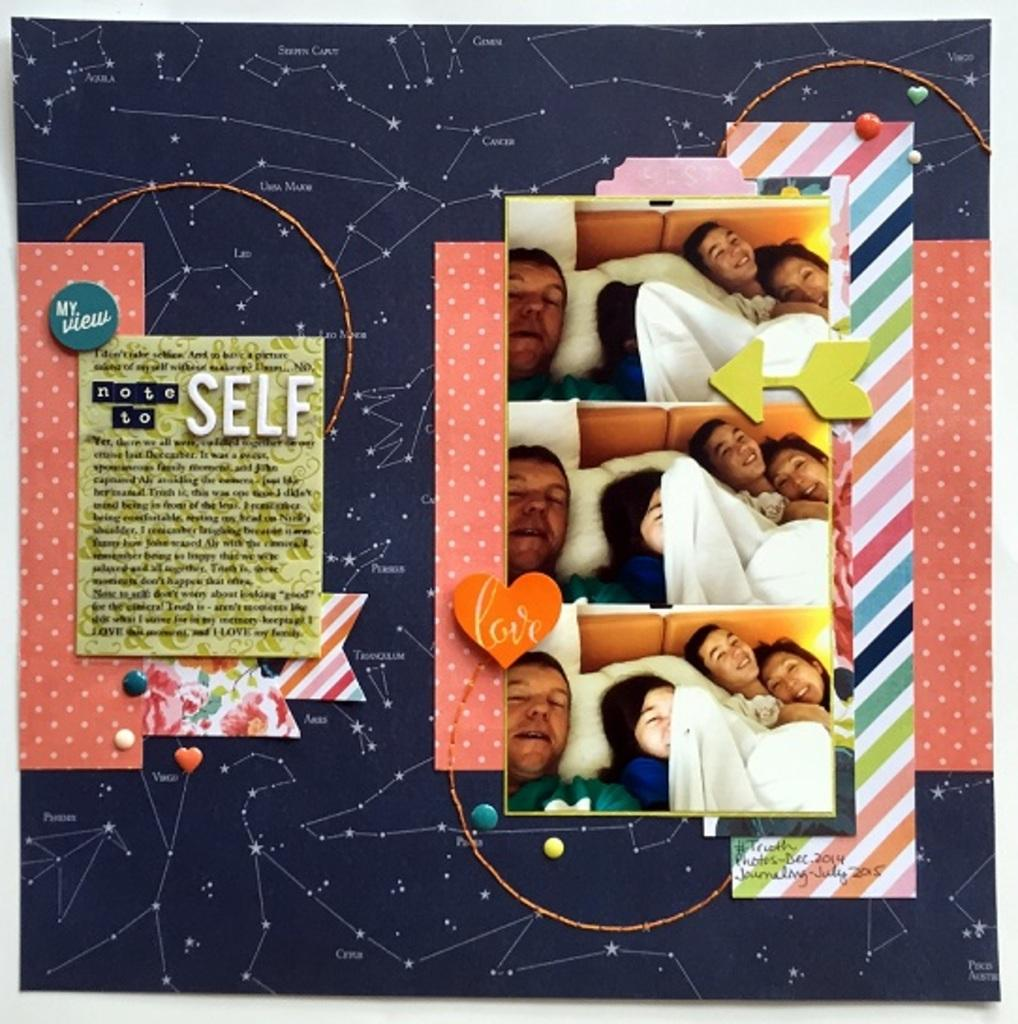What is the main subject of the image? The main subject of the image is a notice board with posts on it. Can you describe the contents of the notice board? Unfortunately, the contents of the posts on the notice board cannot be determined from the image alone. What type of spring can be seen attached to the seat in the image? There is no seat or spring present in the image; it only features a notice board with posts on it. 